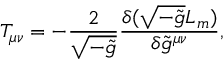<formula> <loc_0><loc_0><loc_500><loc_500>T _ { \mu \nu } = - \frac { 2 } { \sqrt { - \tilde { g } } } \frac { \delta ( \sqrt { - \tilde { g } } L _ { m } ) } { \delta \tilde { g } ^ { \mu \nu } } ,</formula> 